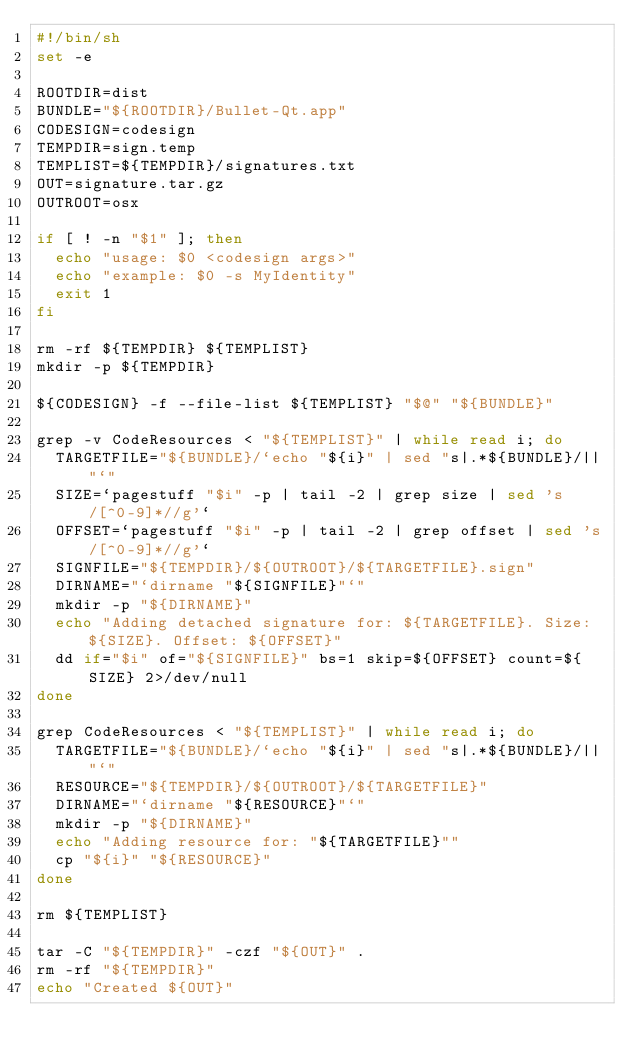Convert code to text. <code><loc_0><loc_0><loc_500><loc_500><_Bash_>#!/bin/sh
set -e

ROOTDIR=dist
BUNDLE="${ROOTDIR}/Bullet-Qt.app"
CODESIGN=codesign
TEMPDIR=sign.temp
TEMPLIST=${TEMPDIR}/signatures.txt
OUT=signature.tar.gz
OUTROOT=osx

if [ ! -n "$1" ]; then
  echo "usage: $0 <codesign args>"
  echo "example: $0 -s MyIdentity"
  exit 1
fi

rm -rf ${TEMPDIR} ${TEMPLIST}
mkdir -p ${TEMPDIR}

${CODESIGN} -f --file-list ${TEMPLIST} "$@" "${BUNDLE}"

grep -v CodeResources < "${TEMPLIST}" | while read i; do
  TARGETFILE="${BUNDLE}/`echo "${i}" | sed "s|.*${BUNDLE}/||"`"
  SIZE=`pagestuff "$i" -p | tail -2 | grep size | sed 's/[^0-9]*//g'`
  OFFSET=`pagestuff "$i" -p | tail -2 | grep offset | sed 's/[^0-9]*//g'`
  SIGNFILE="${TEMPDIR}/${OUTROOT}/${TARGETFILE}.sign"
  DIRNAME="`dirname "${SIGNFILE}"`"
  mkdir -p "${DIRNAME}"
  echo "Adding detached signature for: ${TARGETFILE}. Size: ${SIZE}. Offset: ${OFFSET}"
  dd if="$i" of="${SIGNFILE}" bs=1 skip=${OFFSET} count=${SIZE} 2>/dev/null
done

grep CodeResources < "${TEMPLIST}" | while read i; do
  TARGETFILE="${BUNDLE}/`echo "${i}" | sed "s|.*${BUNDLE}/||"`"
  RESOURCE="${TEMPDIR}/${OUTROOT}/${TARGETFILE}"
  DIRNAME="`dirname "${RESOURCE}"`"
  mkdir -p "${DIRNAME}"
  echo "Adding resource for: "${TARGETFILE}""
  cp "${i}" "${RESOURCE}"
done

rm ${TEMPLIST}

tar -C "${TEMPDIR}" -czf "${OUT}" .
rm -rf "${TEMPDIR}"
echo "Created ${OUT}"
</code> 